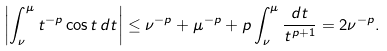<formula> <loc_0><loc_0><loc_500><loc_500>\left | \int _ { \nu } ^ { \mu } t ^ { - p } \cos t \, d t \right | & \leq \nu ^ { - p } + \mu ^ { - p } + p \int _ { \nu } ^ { \mu } \frac { d t } { t ^ { p + 1 } } = 2 \nu ^ { - p } .</formula> 